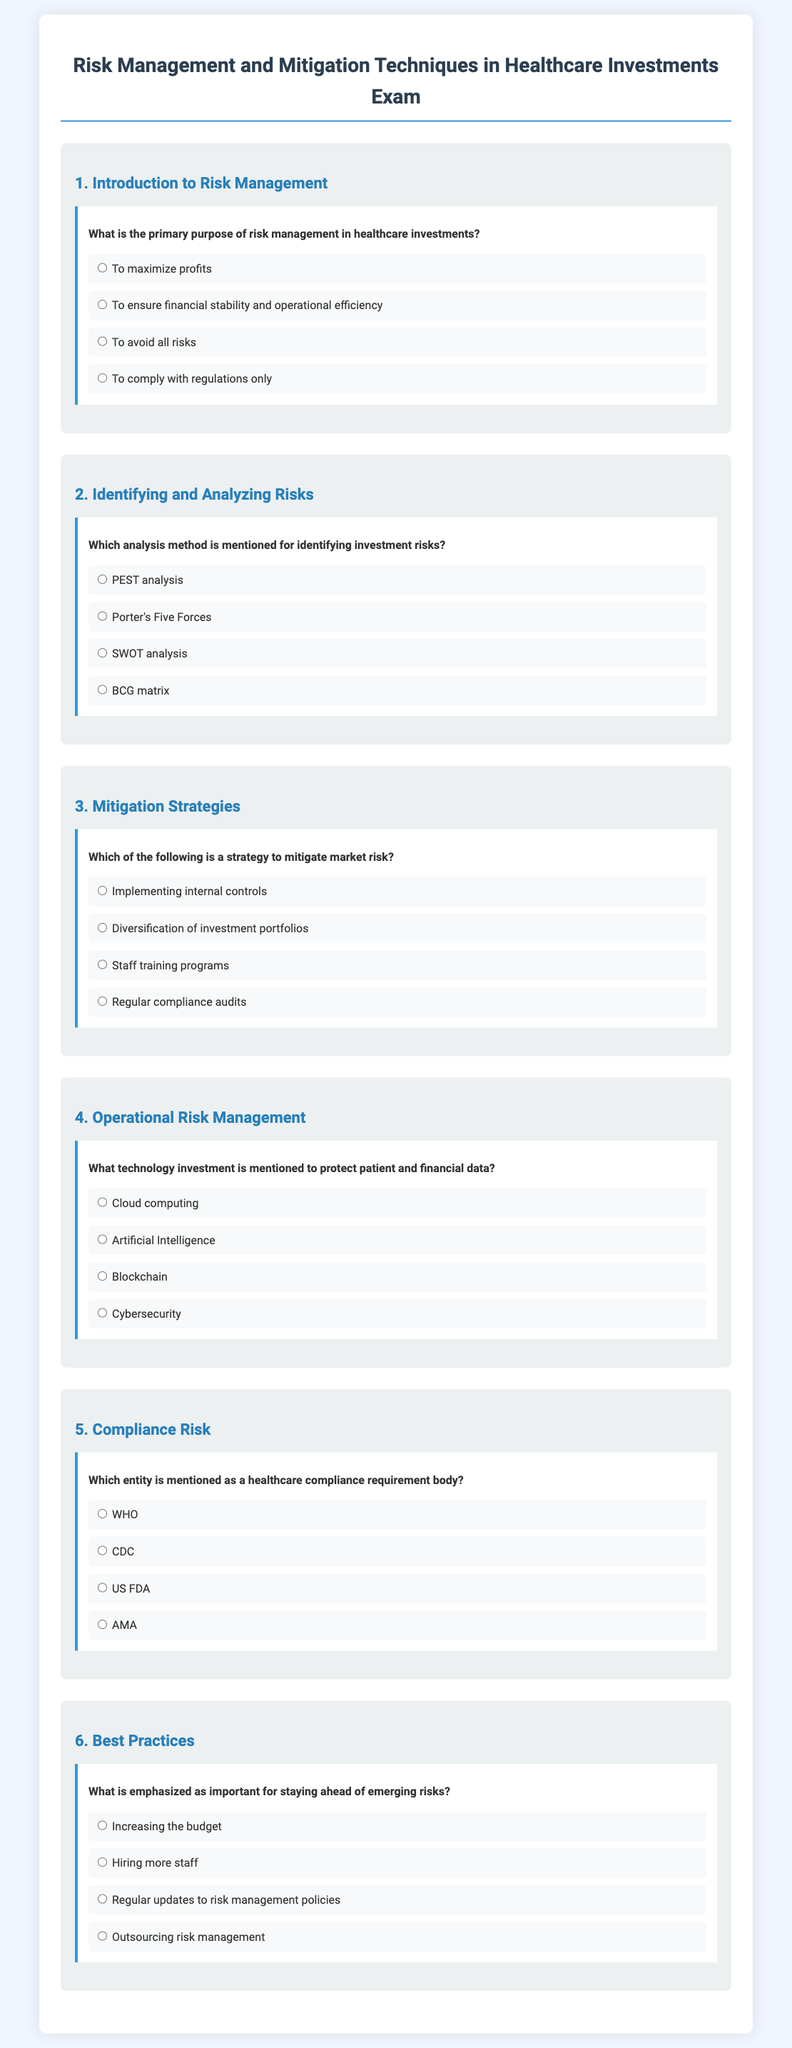What is the primary purpose of risk management in healthcare investments? The primary purpose of risk management in healthcare investments is to ensure financial stability and operational efficiency.
Answer: To ensure financial stability and operational efficiency Which analysis method is mentioned for identifying investment risks? The analysis method mentioned for identifying investment risks in the document is SWOT analysis.
Answer: SWOT analysis What strategy is indicated to mitigate market risk? The document states that diversification of investment portfolios is a strategy to mitigate market risk.
Answer: Diversification of investment portfolios What technology investment is emphasized to protect patient and financial data? The document highlights cybersecurity as the technology investment to protect patient and financial data.
Answer: Cybersecurity Which entity is mentioned as a healthcare compliance requirement body? The US FDA is listed in the document as a healthcare compliance requirement body.
Answer: US FDA What is emphasized as important for staying ahead of emerging risks? The document notes that regular updates to risk management policies are important for staying ahead of emerging risks.
Answer: Regular updates to risk management policies 